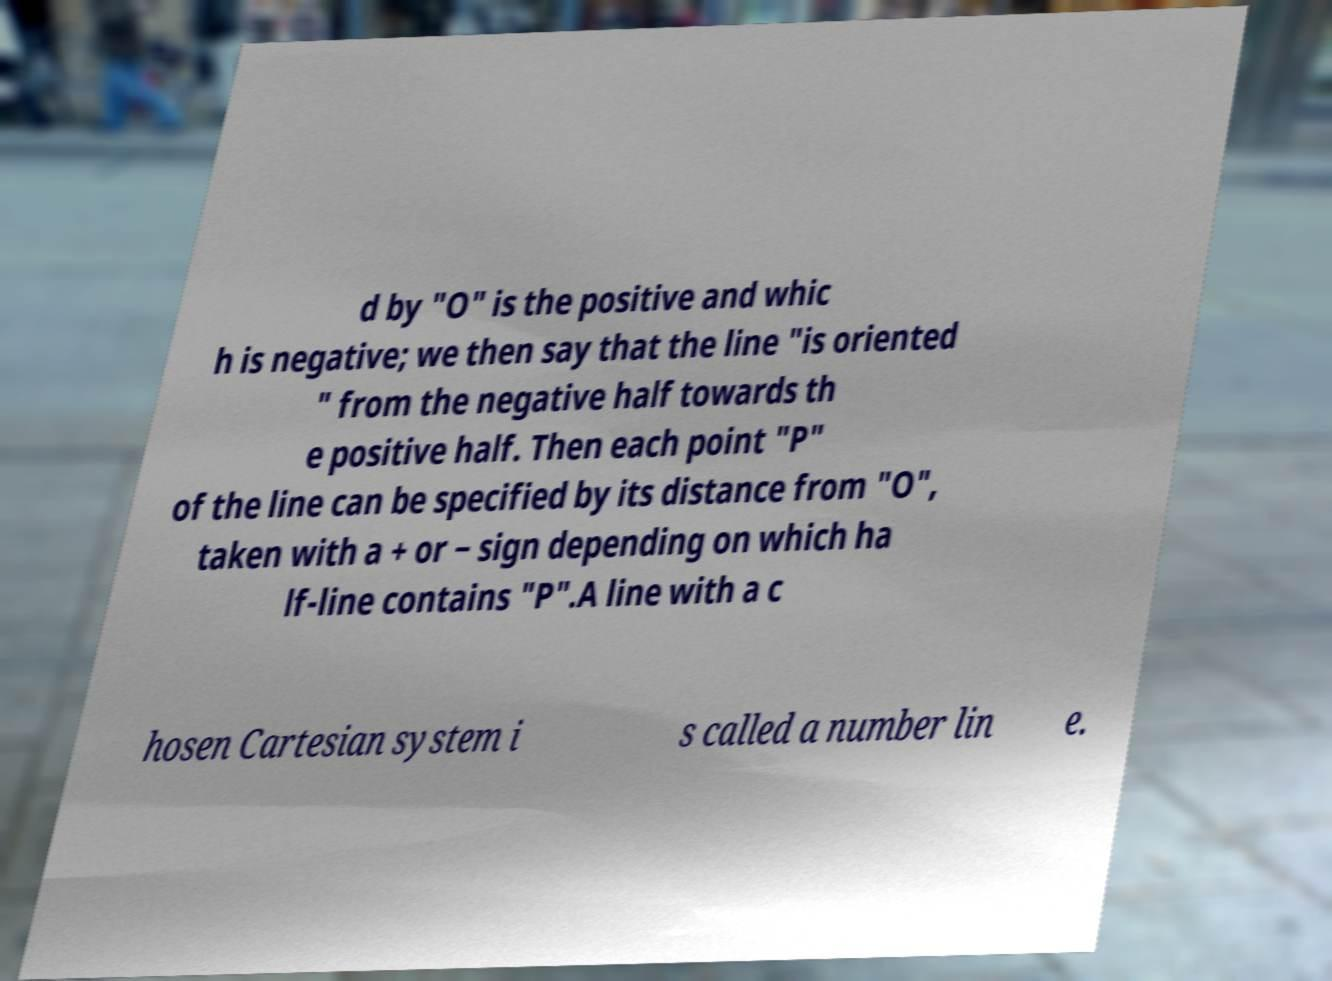Please identify and transcribe the text found in this image. d by "O" is the positive and whic h is negative; we then say that the line "is oriented " from the negative half towards th e positive half. Then each point "P" of the line can be specified by its distance from "O", taken with a + or − sign depending on which ha lf-line contains "P".A line with a c hosen Cartesian system i s called a number lin e. 